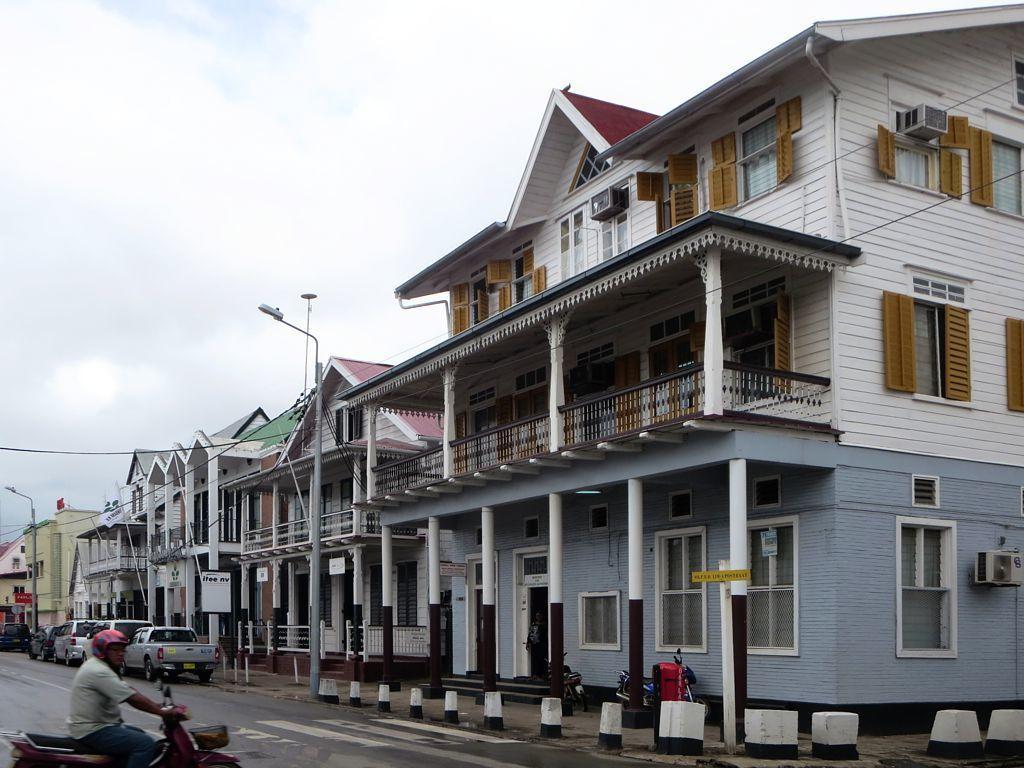Please provide a concise description of this image. In this image, we can see buildings, walls, pillars, railings, glass windows, streetlights, boards and few objects. At the bottom of the image, we can see vehicles are parked on the road. In the bottom left corner of the image, we can see a person riding a vehicle. In the background, there is the cloudy sky. 